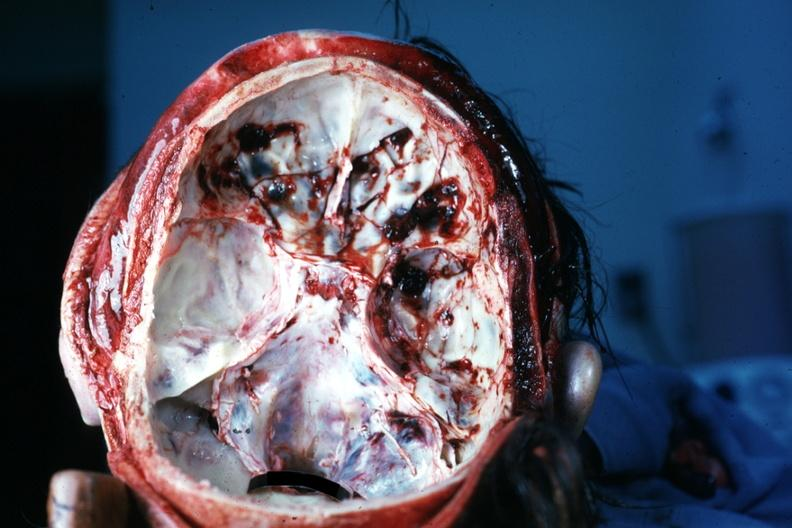s a bulge present?
Answer the question using a single word or phrase. No 